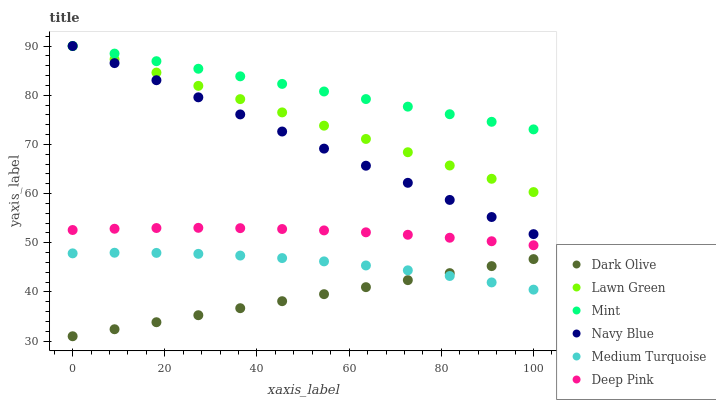Does Dark Olive have the minimum area under the curve?
Answer yes or no. Yes. Does Mint have the maximum area under the curve?
Answer yes or no. Yes. Does Deep Pink have the minimum area under the curve?
Answer yes or no. No. Does Deep Pink have the maximum area under the curve?
Answer yes or no. No. Is Lawn Green the smoothest?
Answer yes or no. Yes. Is Medium Turquoise the roughest?
Answer yes or no. Yes. Is Deep Pink the smoothest?
Answer yes or no. No. Is Deep Pink the roughest?
Answer yes or no. No. Does Dark Olive have the lowest value?
Answer yes or no. Yes. Does Deep Pink have the lowest value?
Answer yes or no. No. Does Mint have the highest value?
Answer yes or no. Yes. Does Deep Pink have the highest value?
Answer yes or no. No. Is Dark Olive less than Deep Pink?
Answer yes or no. Yes. Is Mint greater than Medium Turquoise?
Answer yes or no. Yes. Does Lawn Green intersect Navy Blue?
Answer yes or no. Yes. Is Lawn Green less than Navy Blue?
Answer yes or no. No. Is Lawn Green greater than Navy Blue?
Answer yes or no. No. Does Dark Olive intersect Deep Pink?
Answer yes or no. No. 